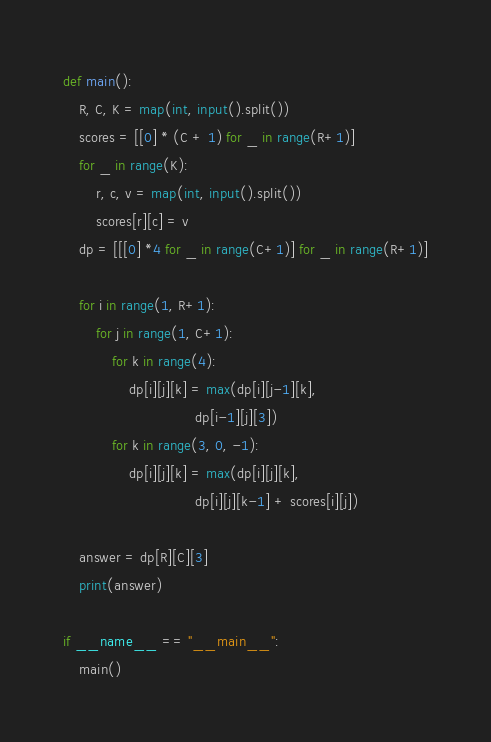<code> <loc_0><loc_0><loc_500><loc_500><_Python_>def main():
    R, C, K = map(int, input().split())
    scores = [[0] * (C + 1) for _ in range(R+1)]
    for _ in range(K):
        r, c, v = map(int, input().split())
        scores[r][c] = v
    dp = [[[0] *4 for _ in range(C+1)] for _ in range(R+1)]

    for i in range(1, R+1):
        for j in range(1, C+1):
            for k in range(4):
                dp[i][j][k] = max(dp[i][j-1][k],
                                dp[i-1][j][3])
            for k in range(3, 0, -1):
                dp[i][j][k] = max(dp[i][j][k],
                                dp[i][j][k-1] + scores[i][j])

    answer = dp[R][C][3]
    print(answer)

if __name__ == "__main__":
    main()</code> 